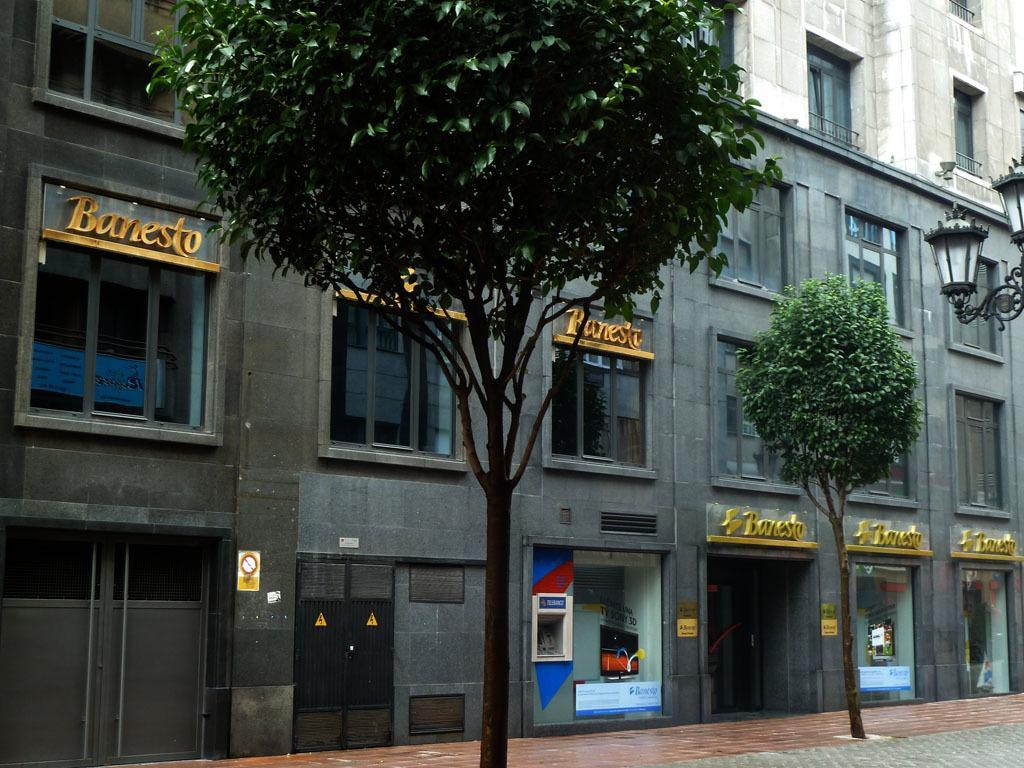In one or two sentences, can you explain what this image depicts? This image consists of a building. In the front, there is a plant and a tree. To the right, there are lights. 